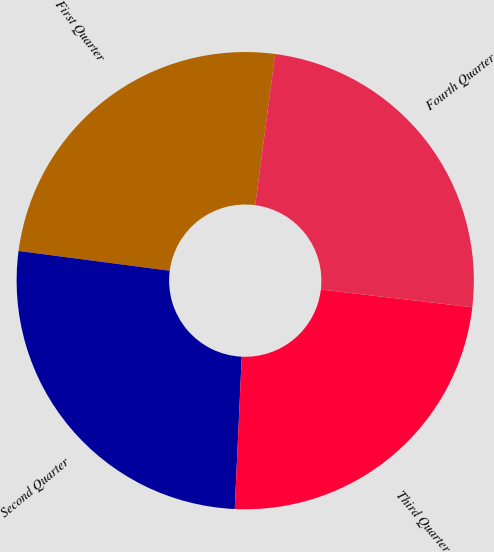Convert chart to OTSL. <chart><loc_0><loc_0><loc_500><loc_500><pie_chart><fcel>First Quarter<fcel>Second Quarter<fcel>Third Quarter<fcel>Fourth Quarter<nl><fcel>25.02%<fcel>26.34%<fcel>23.87%<fcel>24.77%<nl></chart> 